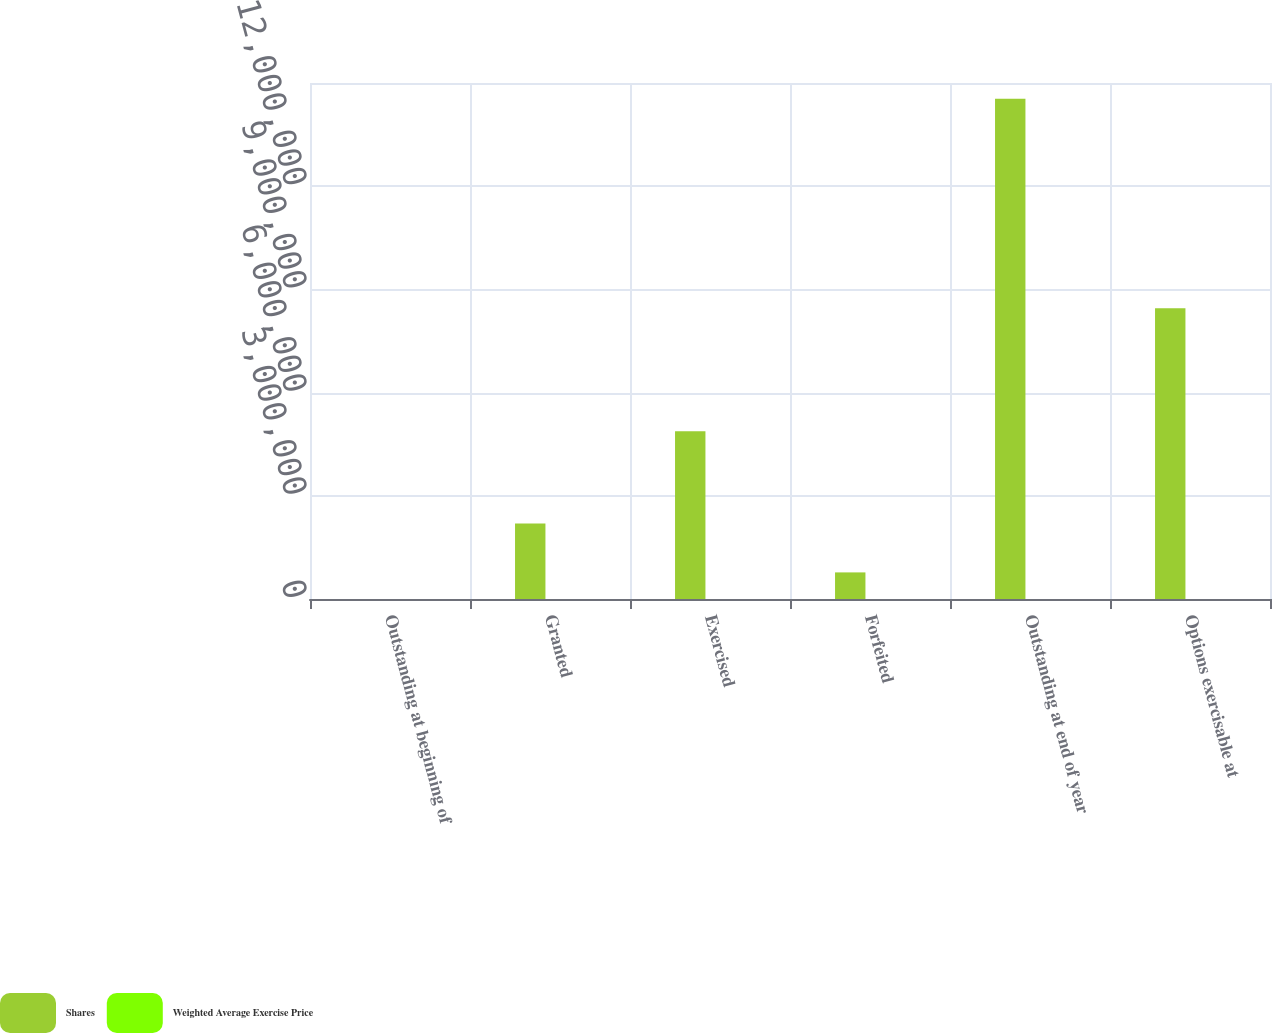Convert chart. <chart><loc_0><loc_0><loc_500><loc_500><stacked_bar_chart><ecel><fcel>Outstanding at beginning of<fcel>Granted<fcel>Exercised<fcel>Forfeited<fcel>Outstanding at end of year<fcel>Options exercisable at<nl><fcel>Shares<fcel>51.62<fcel>2.19163e+06<fcel>4.87512e+06<fcel>773145<fcel>1.45404e+07<fcel>8.45336e+06<nl><fcel>Weighted Average Exercise Price<fcel>42.21<fcel>51.62<fcel>38.3<fcel>43.9<fcel>44.86<fcel>46.95<nl></chart> 